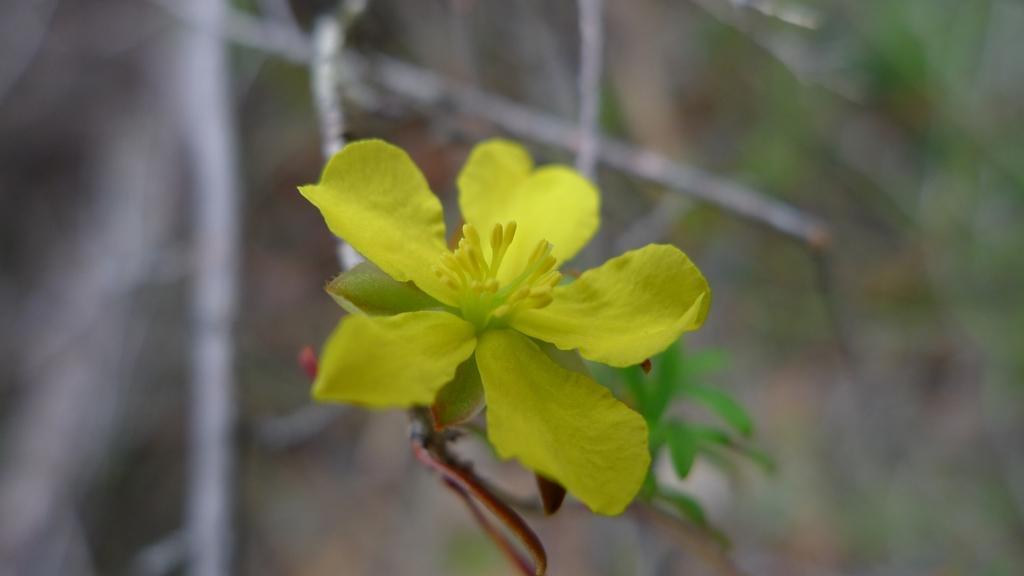In one or two sentences, can you explain what this image depicts? In this image I can see a yellow color flower and green leaves. Background is blurred. 